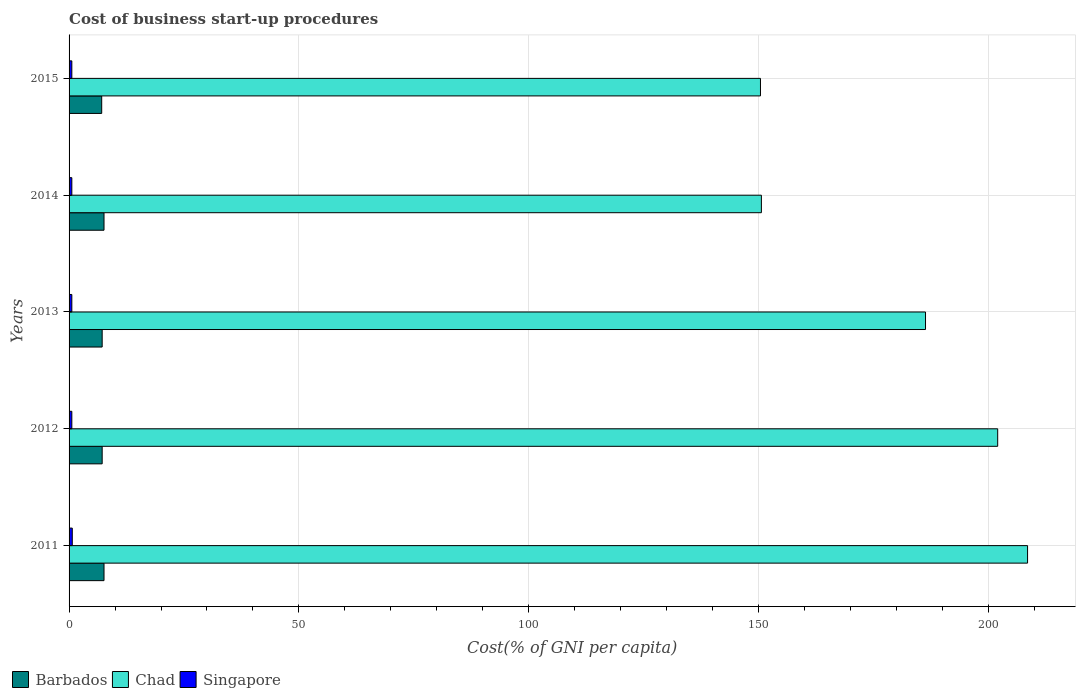How many groups of bars are there?
Provide a succinct answer. 5. Are the number of bars per tick equal to the number of legend labels?
Your response must be concise. Yes. What is the label of the 2nd group of bars from the top?
Make the answer very short. 2014. In how many cases, is the number of bars for a given year not equal to the number of legend labels?
Your answer should be very brief. 0. Across all years, what is the maximum cost of business start-up procedures in Chad?
Provide a succinct answer. 208.5. What is the difference between the cost of business start-up procedures in Singapore in 2011 and that in 2015?
Keep it short and to the point. 0.1. What is the difference between the cost of business start-up procedures in Chad in 2013 and the cost of business start-up procedures in Singapore in 2015?
Make the answer very short. 185.7. What is the average cost of business start-up procedures in Singapore per year?
Give a very brief answer. 0.62. In the year 2011, what is the difference between the cost of business start-up procedures in Singapore and cost of business start-up procedures in Chad?
Offer a terse response. -207.8. In how many years, is the cost of business start-up procedures in Singapore greater than 50 %?
Your answer should be very brief. 0. What is the ratio of the cost of business start-up procedures in Chad in 2013 to that in 2014?
Keep it short and to the point. 1.24. What is the difference between the highest and the lowest cost of business start-up procedures in Chad?
Give a very brief answer. 58.1. In how many years, is the cost of business start-up procedures in Barbados greater than the average cost of business start-up procedures in Barbados taken over all years?
Your answer should be very brief. 2. Is the sum of the cost of business start-up procedures in Barbados in 2012 and 2015 greater than the maximum cost of business start-up procedures in Singapore across all years?
Provide a short and direct response. Yes. What does the 1st bar from the top in 2011 represents?
Your response must be concise. Singapore. What does the 1st bar from the bottom in 2014 represents?
Ensure brevity in your answer.  Barbados. How many bars are there?
Give a very brief answer. 15. Are all the bars in the graph horizontal?
Your answer should be compact. Yes. What is the difference between two consecutive major ticks on the X-axis?
Your answer should be compact. 50. Are the values on the major ticks of X-axis written in scientific E-notation?
Your answer should be compact. No. Does the graph contain grids?
Your answer should be very brief. Yes. Where does the legend appear in the graph?
Keep it short and to the point. Bottom left. How are the legend labels stacked?
Your answer should be very brief. Horizontal. What is the title of the graph?
Keep it short and to the point. Cost of business start-up procedures. Does "Monaco" appear as one of the legend labels in the graph?
Offer a very short reply. No. What is the label or title of the X-axis?
Make the answer very short. Cost(% of GNI per capita). What is the Cost(% of GNI per capita) of Chad in 2011?
Your response must be concise. 208.5. What is the Cost(% of GNI per capita) in Barbados in 2012?
Your response must be concise. 7.2. What is the Cost(% of GNI per capita) in Chad in 2012?
Your answer should be compact. 202. What is the Cost(% of GNI per capita) in Singapore in 2012?
Give a very brief answer. 0.6. What is the Cost(% of GNI per capita) in Barbados in 2013?
Offer a very short reply. 7.2. What is the Cost(% of GNI per capita) of Chad in 2013?
Offer a terse response. 186.3. What is the Cost(% of GNI per capita) of Chad in 2014?
Give a very brief answer. 150.6. What is the Cost(% of GNI per capita) in Singapore in 2014?
Offer a very short reply. 0.6. What is the Cost(% of GNI per capita) in Barbados in 2015?
Your answer should be compact. 7.1. What is the Cost(% of GNI per capita) in Chad in 2015?
Make the answer very short. 150.4. What is the Cost(% of GNI per capita) in Singapore in 2015?
Keep it short and to the point. 0.6. Across all years, what is the maximum Cost(% of GNI per capita) in Chad?
Provide a succinct answer. 208.5. Across all years, what is the minimum Cost(% of GNI per capita) of Chad?
Give a very brief answer. 150.4. What is the total Cost(% of GNI per capita) in Barbados in the graph?
Make the answer very short. 36.7. What is the total Cost(% of GNI per capita) in Chad in the graph?
Offer a terse response. 897.8. What is the difference between the Cost(% of GNI per capita) of Barbados in 2011 and that in 2012?
Your answer should be compact. 0.4. What is the difference between the Cost(% of GNI per capita) in Chad in 2011 and that in 2014?
Provide a succinct answer. 57.9. What is the difference between the Cost(% of GNI per capita) of Barbados in 2011 and that in 2015?
Offer a very short reply. 0.5. What is the difference between the Cost(% of GNI per capita) in Chad in 2011 and that in 2015?
Keep it short and to the point. 58.1. What is the difference between the Cost(% of GNI per capita) in Singapore in 2012 and that in 2013?
Your answer should be very brief. 0. What is the difference between the Cost(% of GNI per capita) in Barbados in 2012 and that in 2014?
Offer a very short reply. -0.4. What is the difference between the Cost(% of GNI per capita) of Chad in 2012 and that in 2014?
Provide a succinct answer. 51.4. What is the difference between the Cost(% of GNI per capita) in Singapore in 2012 and that in 2014?
Give a very brief answer. 0. What is the difference between the Cost(% of GNI per capita) in Chad in 2012 and that in 2015?
Keep it short and to the point. 51.6. What is the difference between the Cost(% of GNI per capita) in Barbados in 2013 and that in 2014?
Offer a terse response. -0.4. What is the difference between the Cost(% of GNI per capita) of Chad in 2013 and that in 2014?
Give a very brief answer. 35.7. What is the difference between the Cost(% of GNI per capita) of Singapore in 2013 and that in 2014?
Your answer should be compact. 0. What is the difference between the Cost(% of GNI per capita) of Chad in 2013 and that in 2015?
Your answer should be compact. 35.9. What is the difference between the Cost(% of GNI per capita) of Barbados in 2014 and that in 2015?
Keep it short and to the point. 0.5. What is the difference between the Cost(% of GNI per capita) in Singapore in 2014 and that in 2015?
Provide a short and direct response. 0. What is the difference between the Cost(% of GNI per capita) of Barbados in 2011 and the Cost(% of GNI per capita) of Chad in 2012?
Provide a short and direct response. -194.4. What is the difference between the Cost(% of GNI per capita) in Chad in 2011 and the Cost(% of GNI per capita) in Singapore in 2012?
Ensure brevity in your answer.  207.9. What is the difference between the Cost(% of GNI per capita) in Barbados in 2011 and the Cost(% of GNI per capita) in Chad in 2013?
Provide a short and direct response. -178.7. What is the difference between the Cost(% of GNI per capita) in Chad in 2011 and the Cost(% of GNI per capita) in Singapore in 2013?
Your response must be concise. 207.9. What is the difference between the Cost(% of GNI per capita) of Barbados in 2011 and the Cost(% of GNI per capita) of Chad in 2014?
Your response must be concise. -143. What is the difference between the Cost(% of GNI per capita) of Barbados in 2011 and the Cost(% of GNI per capita) of Singapore in 2014?
Your answer should be compact. 7. What is the difference between the Cost(% of GNI per capita) in Chad in 2011 and the Cost(% of GNI per capita) in Singapore in 2014?
Provide a short and direct response. 207.9. What is the difference between the Cost(% of GNI per capita) in Barbados in 2011 and the Cost(% of GNI per capita) in Chad in 2015?
Give a very brief answer. -142.8. What is the difference between the Cost(% of GNI per capita) of Barbados in 2011 and the Cost(% of GNI per capita) of Singapore in 2015?
Ensure brevity in your answer.  7. What is the difference between the Cost(% of GNI per capita) of Chad in 2011 and the Cost(% of GNI per capita) of Singapore in 2015?
Your answer should be compact. 207.9. What is the difference between the Cost(% of GNI per capita) of Barbados in 2012 and the Cost(% of GNI per capita) of Chad in 2013?
Ensure brevity in your answer.  -179.1. What is the difference between the Cost(% of GNI per capita) of Barbados in 2012 and the Cost(% of GNI per capita) of Singapore in 2013?
Provide a succinct answer. 6.6. What is the difference between the Cost(% of GNI per capita) in Chad in 2012 and the Cost(% of GNI per capita) in Singapore in 2013?
Ensure brevity in your answer.  201.4. What is the difference between the Cost(% of GNI per capita) in Barbados in 2012 and the Cost(% of GNI per capita) in Chad in 2014?
Your answer should be very brief. -143.4. What is the difference between the Cost(% of GNI per capita) of Barbados in 2012 and the Cost(% of GNI per capita) of Singapore in 2014?
Offer a very short reply. 6.6. What is the difference between the Cost(% of GNI per capita) of Chad in 2012 and the Cost(% of GNI per capita) of Singapore in 2014?
Offer a very short reply. 201.4. What is the difference between the Cost(% of GNI per capita) in Barbados in 2012 and the Cost(% of GNI per capita) in Chad in 2015?
Offer a terse response. -143.2. What is the difference between the Cost(% of GNI per capita) of Barbados in 2012 and the Cost(% of GNI per capita) of Singapore in 2015?
Give a very brief answer. 6.6. What is the difference between the Cost(% of GNI per capita) of Chad in 2012 and the Cost(% of GNI per capita) of Singapore in 2015?
Offer a very short reply. 201.4. What is the difference between the Cost(% of GNI per capita) of Barbados in 2013 and the Cost(% of GNI per capita) of Chad in 2014?
Your response must be concise. -143.4. What is the difference between the Cost(% of GNI per capita) in Chad in 2013 and the Cost(% of GNI per capita) in Singapore in 2014?
Provide a succinct answer. 185.7. What is the difference between the Cost(% of GNI per capita) in Barbados in 2013 and the Cost(% of GNI per capita) in Chad in 2015?
Your answer should be compact. -143.2. What is the difference between the Cost(% of GNI per capita) in Chad in 2013 and the Cost(% of GNI per capita) in Singapore in 2015?
Give a very brief answer. 185.7. What is the difference between the Cost(% of GNI per capita) in Barbados in 2014 and the Cost(% of GNI per capita) in Chad in 2015?
Give a very brief answer. -142.8. What is the difference between the Cost(% of GNI per capita) in Chad in 2014 and the Cost(% of GNI per capita) in Singapore in 2015?
Keep it short and to the point. 150. What is the average Cost(% of GNI per capita) of Barbados per year?
Provide a short and direct response. 7.34. What is the average Cost(% of GNI per capita) of Chad per year?
Provide a succinct answer. 179.56. What is the average Cost(% of GNI per capita) of Singapore per year?
Give a very brief answer. 0.62. In the year 2011, what is the difference between the Cost(% of GNI per capita) of Barbados and Cost(% of GNI per capita) of Chad?
Ensure brevity in your answer.  -200.9. In the year 2011, what is the difference between the Cost(% of GNI per capita) in Chad and Cost(% of GNI per capita) in Singapore?
Offer a terse response. 207.8. In the year 2012, what is the difference between the Cost(% of GNI per capita) in Barbados and Cost(% of GNI per capita) in Chad?
Offer a very short reply. -194.8. In the year 2012, what is the difference between the Cost(% of GNI per capita) of Barbados and Cost(% of GNI per capita) of Singapore?
Offer a very short reply. 6.6. In the year 2012, what is the difference between the Cost(% of GNI per capita) of Chad and Cost(% of GNI per capita) of Singapore?
Provide a short and direct response. 201.4. In the year 2013, what is the difference between the Cost(% of GNI per capita) of Barbados and Cost(% of GNI per capita) of Chad?
Your answer should be compact. -179.1. In the year 2013, what is the difference between the Cost(% of GNI per capita) in Barbados and Cost(% of GNI per capita) in Singapore?
Make the answer very short. 6.6. In the year 2013, what is the difference between the Cost(% of GNI per capita) of Chad and Cost(% of GNI per capita) of Singapore?
Keep it short and to the point. 185.7. In the year 2014, what is the difference between the Cost(% of GNI per capita) of Barbados and Cost(% of GNI per capita) of Chad?
Provide a succinct answer. -143. In the year 2014, what is the difference between the Cost(% of GNI per capita) in Chad and Cost(% of GNI per capita) in Singapore?
Make the answer very short. 150. In the year 2015, what is the difference between the Cost(% of GNI per capita) in Barbados and Cost(% of GNI per capita) in Chad?
Your response must be concise. -143.3. In the year 2015, what is the difference between the Cost(% of GNI per capita) in Chad and Cost(% of GNI per capita) in Singapore?
Ensure brevity in your answer.  149.8. What is the ratio of the Cost(% of GNI per capita) in Barbados in 2011 to that in 2012?
Provide a short and direct response. 1.06. What is the ratio of the Cost(% of GNI per capita) of Chad in 2011 to that in 2012?
Your response must be concise. 1.03. What is the ratio of the Cost(% of GNI per capita) of Singapore in 2011 to that in 2012?
Give a very brief answer. 1.17. What is the ratio of the Cost(% of GNI per capita) of Barbados in 2011 to that in 2013?
Your response must be concise. 1.06. What is the ratio of the Cost(% of GNI per capita) in Chad in 2011 to that in 2013?
Your response must be concise. 1.12. What is the ratio of the Cost(% of GNI per capita) of Barbados in 2011 to that in 2014?
Offer a very short reply. 1. What is the ratio of the Cost(% of GNI per capita) of Chad in 2011 to that in 2014?
Provide a succinct answer. 1.38. What is the ratio of the Cost(% of GNI per capita) of Singapore in 2011 to that in 2014?
Your answer should be compact. 1.17. What is the ratio of the Cost(% of GNI per capita) in Barbados in 2011 to that in 2015?
Give a very brief answer. 1.07. What is the ratio of the Cost(% of GNI per capita) of Chad in 2011 to that in 2015?
Ensure brevity in your answer.  1.39. What is the ratio of the Cost(% of GNI per capita) in Chad in 2012 to that in 2013?
Your answer should be very brief. 1.08. What is the ratio of the Cost(% of GNI per capita) of Barbados in 2012 to that in 2014?
Ensure brevity in your answer.  0.95. What is the ratio of the Cost(% of GNI per capita) in Chad in 2012 to that in 2014?
Make the answer very short. 1.34. What is the ratio of the Cost(% of GNI per capita) of Barbados in 2012 to that in 2015?
Give a very brief answer. 1.01. What is the ratio of the Cost(% of GNI per capita) of Chad in 2012 to that in 2015?
Ensure brevity in your answer.  1.34. What is the ratio of the Cost(% of GNI per capita) in Chad in 2013 to that in 2014?
Provide a succinct answer. 1.24. What is the ratio of the Cost(% of GNI per capita) of Singapore in 2013 to that in 2014?
Your response must be concise. 1. What is the ratio of the Cost(% of GNI per capita) in Barbados in 2013 to that in 2015?
Make the answer very short. 1.01. What is the ratio of the Cost(% of GNI per capita) of Chad in 2013 to that in 2015?
Offer a very short reply. 1.24. What is the ratio of the Cost(% of GNI per capita) of Singapore in 2013 to that in 2015?
Offer a very short reply. 1. What is the ratio of the Cost(% of GNI per capita) in Barbados in 2014 to that in 2015?
Provide a succinct answer. 1.07. What is the ratio of the Cost(% of GNI per capita) in Chad in 2014 to that in 2015?
Keep it short and to the point. 1. What is the ratio of the Cost(% of GNI per capita) in Singapore in 2014 to that in 2015?
Ensure brevity in your answer.  1. What is the difference between the highest and the second highest Cost(% of GNI per capita) of Chad?
Provide a succinct answer. 6.5. What is the difference between the highest and the second highest Cost(% of GNI per capita) of Singapore?
Keep it short and to the point. 0.1. What is the difference between the highest and the lowest Cost(% of GNI per capita) of Chad?
Your answer should be compact. 58.1. What is the difference between the highest and the lowest Cost(% of GNI per capita) in Singapore?
Offer a terse response. 0.1. 